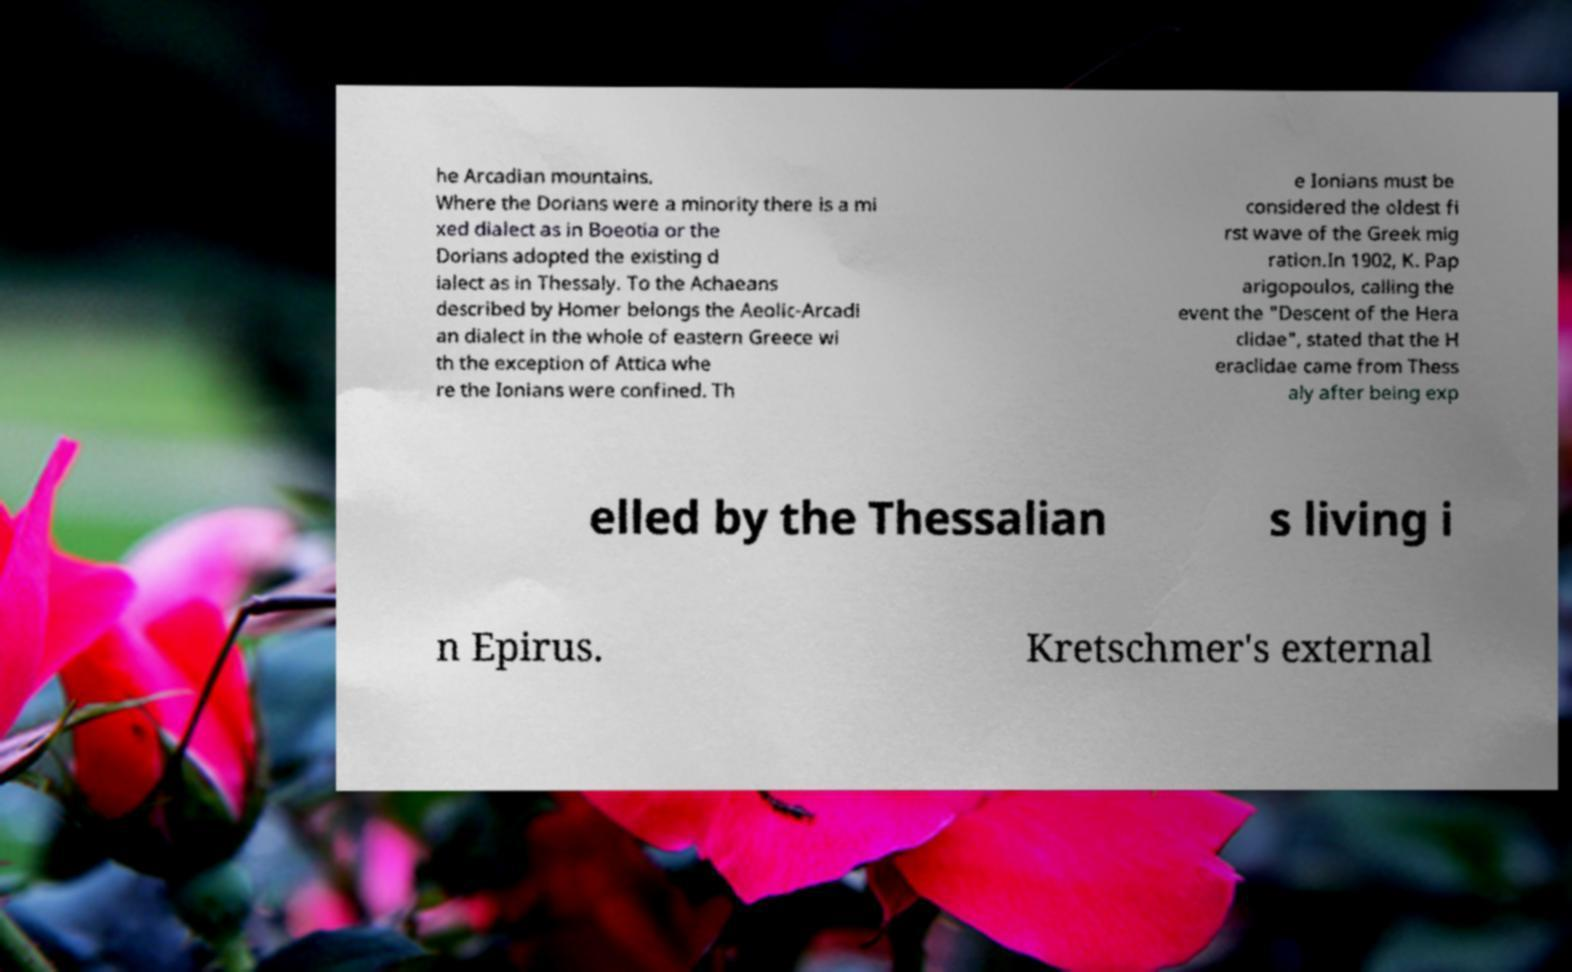Could you extract and type out the text from this image? he Arcadian mountains. Where the Dorians were a minority there is a mi xed dialect as in Boeotia or the Dorians adopted the existing d ialect as in Thessaly. To the Achaeans described by Homer belongs the Aeolic-Arcadi an dialect in the whole of eastern Greece wi th the exception of Attica whe re the Ionians were confined. Th e Ionians must be considered the oldest fi rst wave of the Greek mig ration.In 1902, K. Pap arigopoulos, calling the event the "Descent of the Hera clidae", stated that the H eraclidae came from Thess aly after being exp elled by the Thessalian s living i n Epirus. Kretschmer's external 